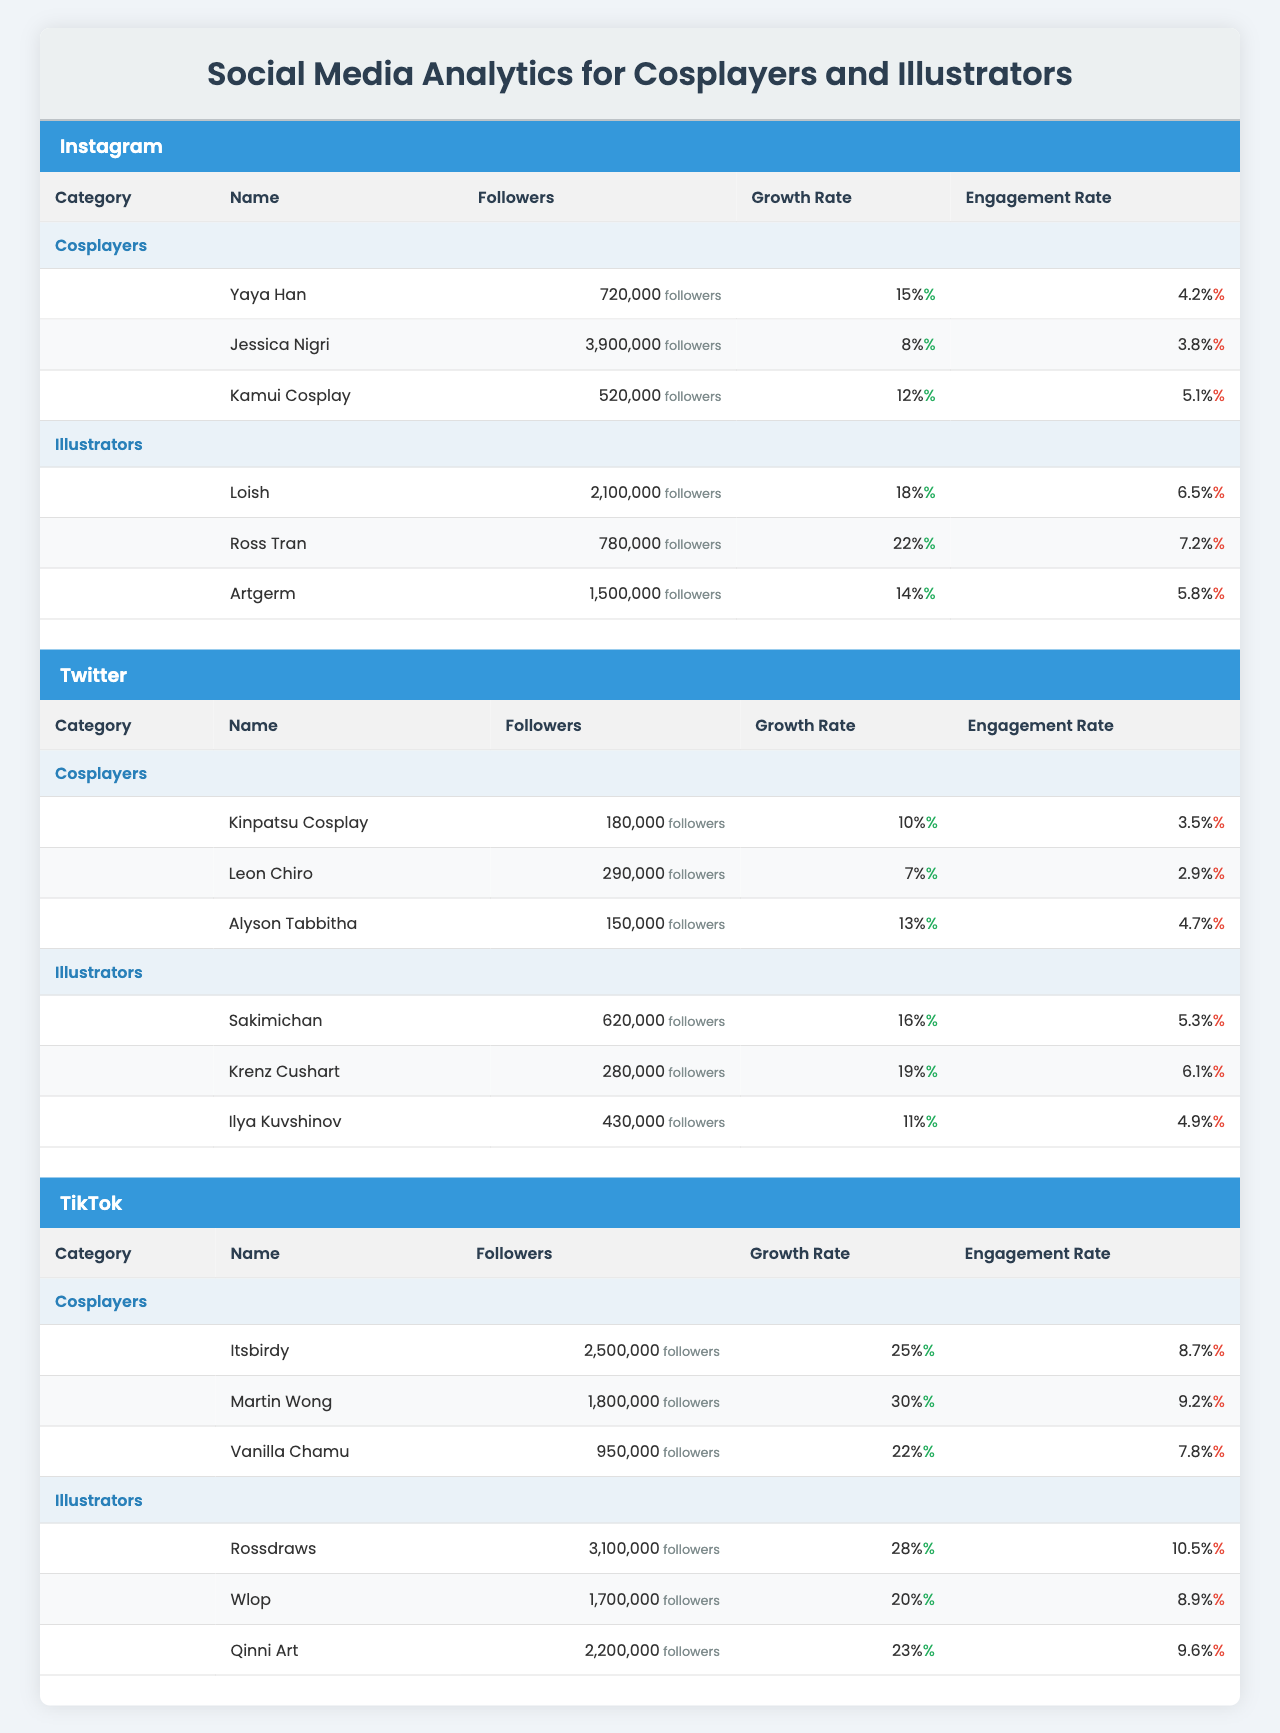What is the total number of followers for all cosplayers on Instagram? The followers for the cosplayers on Instagram are: Yaya Han (720,000), Jessica Nigri (3,900,000), and Kamui Cosplay (520,000). Adding these together: 720,000 + 3,900,000 + 520,000 = 5,140,000.
Answer: 5,140,000 Which illustrator has the highest engagement rate on Instagram? From the table, the engagement rates for illustrators on Instagram are: Loish (6.5%), Ross Tran (7.2%), and Artgerm (5.8%). The highest rate is 7.2% from Ross Tran.
Answer: Ross Tran What is the average growth rate for cosplayers on TikTok? The growth rates for cosplayers on TikTok are: Itsbirdy (25%), Martin Wong (30%), and Vanilla Chamu (22%). The sum is 25 + 30 + 22 = 77, and there are 3 cosplayers, so the average is 77 / 3 = 25.67%.
Answer: 25.67% Do any illustrators on Twitter have a growth rate greater than 15%? The growth rates for illustrators on Twitter are: Sakimichan (16%), Krenz Cushart (19%), and Ilya Kuvshinov (11%). Sakimichan and Krenz Cushart both have growth rates greater than 15%, while Ilya does not.
Answer: Yes What is the difference in followers between the top cosplayer and top illustrator on TikTok? The top cosplayer on TikTok is Itsbirdy with 2,500,000 followers, and the top illustrator is Rossdraws with 3,100,000 followers. The difference in followers is 3,100,000 - 2,500,000 = 600,000.
Answer: 600,000 Which platform has the highest average engagement rate for cosplayers? On Instagram, the engagement rates are: Yaya Han (4.2%), Jessica Nigri (3.8%), and Kamui Cosplay (5.1%). Sum = 4.2 + 3.8 + 5.1 = 13.1%, average = 13.1 / 3 = 4.37%. On Twitter: Kinpatsu Cosplay (3.5%), Leon Chiro (2.9%), Alyson Tabbitha (4.7%), Sum = 11.1%, average = 11.1 / 3 = 3.7%. On TikTok: Itsbirdy (8.7%), Martin Wong (9.2%), Vanilla Chamu (7.8%), Sum = 25.7%, average = 25.7 / 3 = 8.57%. The highest average is for TikTok with 8.57%.
Answer: TikTok Which cosplayer has more followers, Kamui Cosplay or Alyson Tabbitha? Kamui Cosplay has 520,000 followers, and Alyson Tabbitha has 150,000 followers. Comparing the numbers, 520,000 > 150,000, so Kamui has more followers.
Answer: Kamui Cosplay What is the total engagement rate for all illustrators on Instagram? The engagement rates for illustrators on Instagram are: Loish (6.5%), Ross Tran (7.2%), and Artgerm (5.8%). Adding these rates gives us: 6.5 + 7.2 + 5.8 = 19.5%.
Answer: 19.5% Is there a cosplayer with more than 1 million followers on Twitter? The followers for cosplayers on Twitter are: Kinpatsu Cosplay (180,000), Leon Chiro (290,000), and Alyson Tabbitha (150,000). All of these values are below 1 million, so there is no cosplayer above that threshold.
Answer: No 